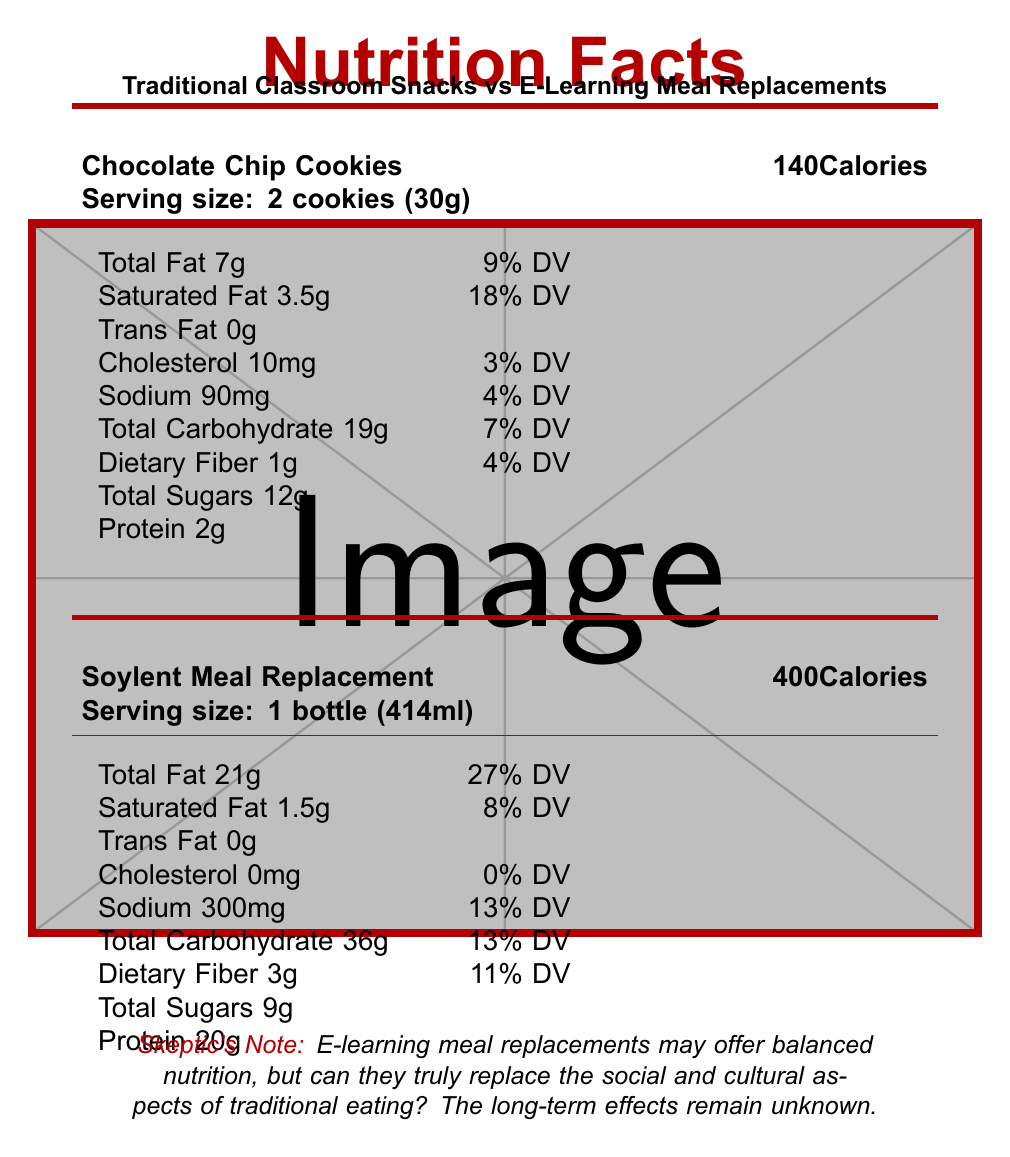what is the serving size for Chocolate Chip Cookies? The document states the serving size for Chocolate Chip Cookies is "2 cookies (30g)", as noted in the specific section for this snack.
Answer: 2 cookies (30g) how many calories are in the Soylent Meal Replacement? The document provides this information in the section dedicated to Soylent Meal Replacement, indicating it contains 400 calories.
Answer: 400 calories what percentage of daily value (DV) of saturated fat does Huel Powder v3.0 have? The Huel Powder v3.0 section lists saturated fat as 2.5g, which accounts for 13% of the Daily Value.
Answer: 13% DV does the Apple Slices with Peanut Butter snack contain any cholesterol? The document specifies that Apple Slices with Peanut Butter contain 0mg cholesterol.
Answer: No what is the sodium content in Chocolate Chip Cookies? The document indicates that Chocolate Chip Cookies have a sodium content of 90mg.
Answer: 90mg which item has the highest amount of protein? 
A. Chocolate Chip Cookies 
B. Apple Slices with Peanut Butter 
C. Soylent Meal Replacement Shake 
D. Huel Powder v3.0 According to the document, Huel Powder v3.0 has 30g of protein, which is the highest compared to the other options provided.
Answer: D what is the total carbohydrate content in Soylent Meal Replacement Shake? 
A. 19g 
B. 31g 
C. 36g 
D. 45g The Soylent Meal Replacement Shake has 36g of total carbohydrates as listed in the document.
Answer: C do traditional classroom snacks generally contain more sugar compared to e-learning meal replacements? The document notes that traditional classroom snacks often have higher sugar content, as seen with Chocolate Chip Cookies (12g) and Apple Slices with Peanut Butter (21g), which are higher compared to the Soylent Shake (9g) and the Huel Powder (1g).
Answer: Yes summarize the main nutritional differences highlighted in the document between traditional classroom snacks and e-learning meal replacements. The document compares traditional snacks and meal replacements in terms of their nutritional value. Traditional snacks are noted for higher sugar content and lack of essential nutrients. In contrast, meal replacements provide a more balanced nutrition with high protein content and added vitamins and minerals. It also touches upon non-nutritional aspects such as the sensory experience and social interaction associated with traditional snacks.
Answer: Traditional snacks like Chocolate Chip Cookies and Apple Slices with Peanut Butter are generally higher in sugars and may lack essential nutrients, whereas e-learning meal replacements like Soylent and Huel offer a balanced nutritional profile with higher protein and additional vitamins and minerals. which snack has the highest total carbohydrate content? The document indicates Huel Powder v3.0 has 45g of total carbohydrates, the highest among the listed items.
Answer: Huel Powder v3.0 how is the emotional satisfaction from traditional snacks compared to e-learning meal replacements as per the document? The document mentions that traditional snacks may provide more sensory satisfaction compared to e-learning meal replacements, indicating the latter might not fully cater to taste preferences and cultural food traditions.
Answer: Traditional snacks are suggested to have higher sensory satisfaction. which item contains the most vitamin D according to the document? The document lists both Soylent Meal Replacement Shake and Huel Powder v3.0 as having 20% of the Daily Value for vitamin D.
Answer: All e-learning meal replacements have 20% DV of vitamin D. does the document provide information on the long-term health effects of relying on meal replacements? The document specifically notes that the long-term effects of relying on meal replacements instead of whole foods are not yet fully understood.
Answer: No 